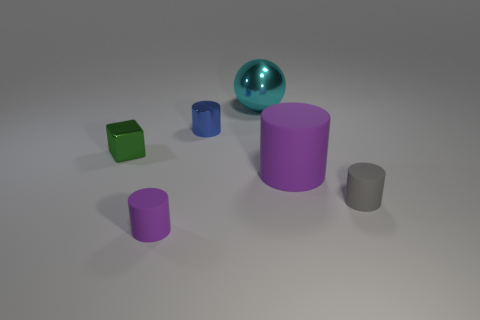Subtract all matte cylinders. How many cylinders are left? 1 Add 3 brown shiny cubes. How many objects exist? 9 Subtract all purple cylinders. How many cylinders are left? 2 Subtract 4 cylinders. How many cylinders are left? 0 Subtract all purple cubes. How many purple cylinders are left? 2 Subtract all spheres. How many objects are left? 5 Add 6 large shiny things. How many large shiny things are left? 7 Add 3 small blue cylinders. How many small blue cylinders exist? 4 Subtract 0 brown balls. How many objects are left? 6 Subtract all cyan cylinders. Subtract all gray blocks. How many cylinders are left? 4 